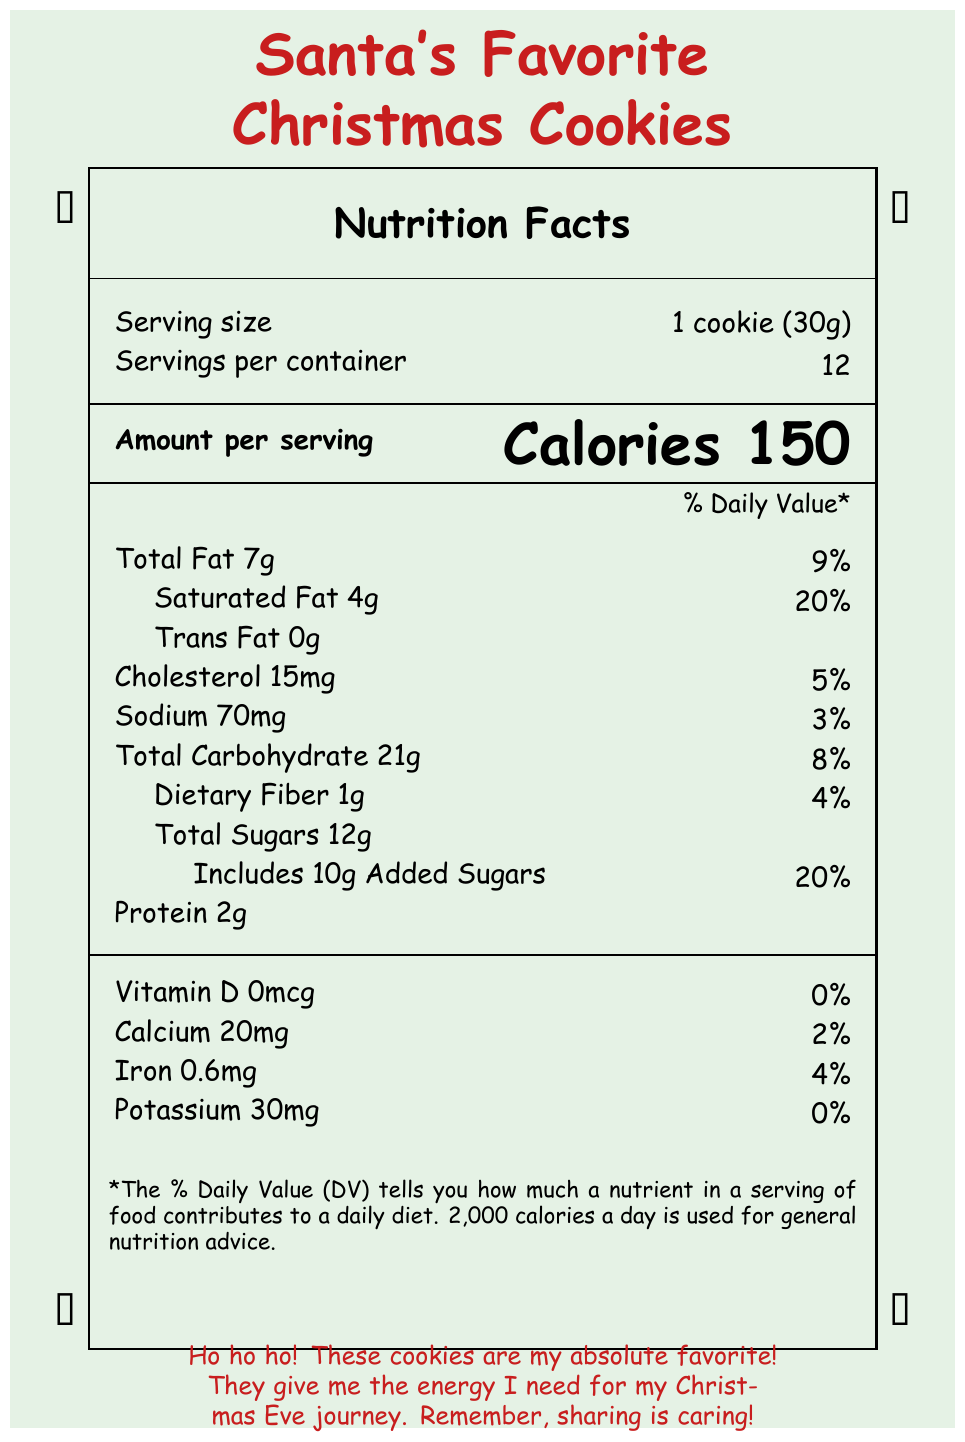what is the serving size? The serving size is listed under the "Serving size" section in the document as "1 cookie (30g)".
Answer: 1 cookie (30g) how many servings are in one container? The document states "Servings per container" with the value of 12.
Answer: 12 how many calories are in one serving? The document lists "Calories" as 150 for one serving.
Answer: 150 how much saturated fat does one cookie contain? The amount of saturated fat per serving is indicated as 4g.
Answer: 4g which ingredient adds a festive touch to the cookies? A. Vanilla extract B. Candy cane pieces C. Baking soda D. Chocolate chips "Candy cane pieces" are listed among the ingredients, making them a festive addition.
Answer: B what percentage of daily value does the sodium content represent? The document states that the sodium content has a daily value percentage of 3%.
Answer: 3% what allergens are contained in the cookies? The allergens section specifies "Contains wheat, milk, eggs".
Answer: Contains wheat, milk, eggs do the cookies contain any vitamin D? The "Vitamin D" section states "0mcg" and "0%".
Answer: No what is the total carbohydrate content per cookie? The "Total Carbohydrate" section lists "21g".
Answer: 21g are these cookies elf approved? It is mentioned in the document that the cookies are "elf approved".
Answer: Yes how much protein is in one serving? The document specifies "Protein 2g".
Answer: 2g which holiday does Santa’s note mention these cookies help with? A. Halloween B. Easter C. Christmas Santa's note mentions his journey on "Christmas Eve", indicating the holiday is Christmas.
Answer: C list two nutrients and their daily values found in these cookies The document lists the daily values for Saturated Fat and Calcium as 20% and 2%, respectively.
Answer: Saturated Fat 20%, Calcium 2% what is the purpose of the note from Santa included in the document? The note from Santa explains that he loves these cookies because they give him energy for his Christmas Eve journey and also adds a reminder that sharing is caring.
Answer: To express how the cookies give him energy for his Christmas Eve journey and emphasize sharing can you determine the exact quantity of butter in the ingredients? The document lists "Butter" among the ingredients, but it does not specify the exact quantity.
Answer: Cannot be determined 